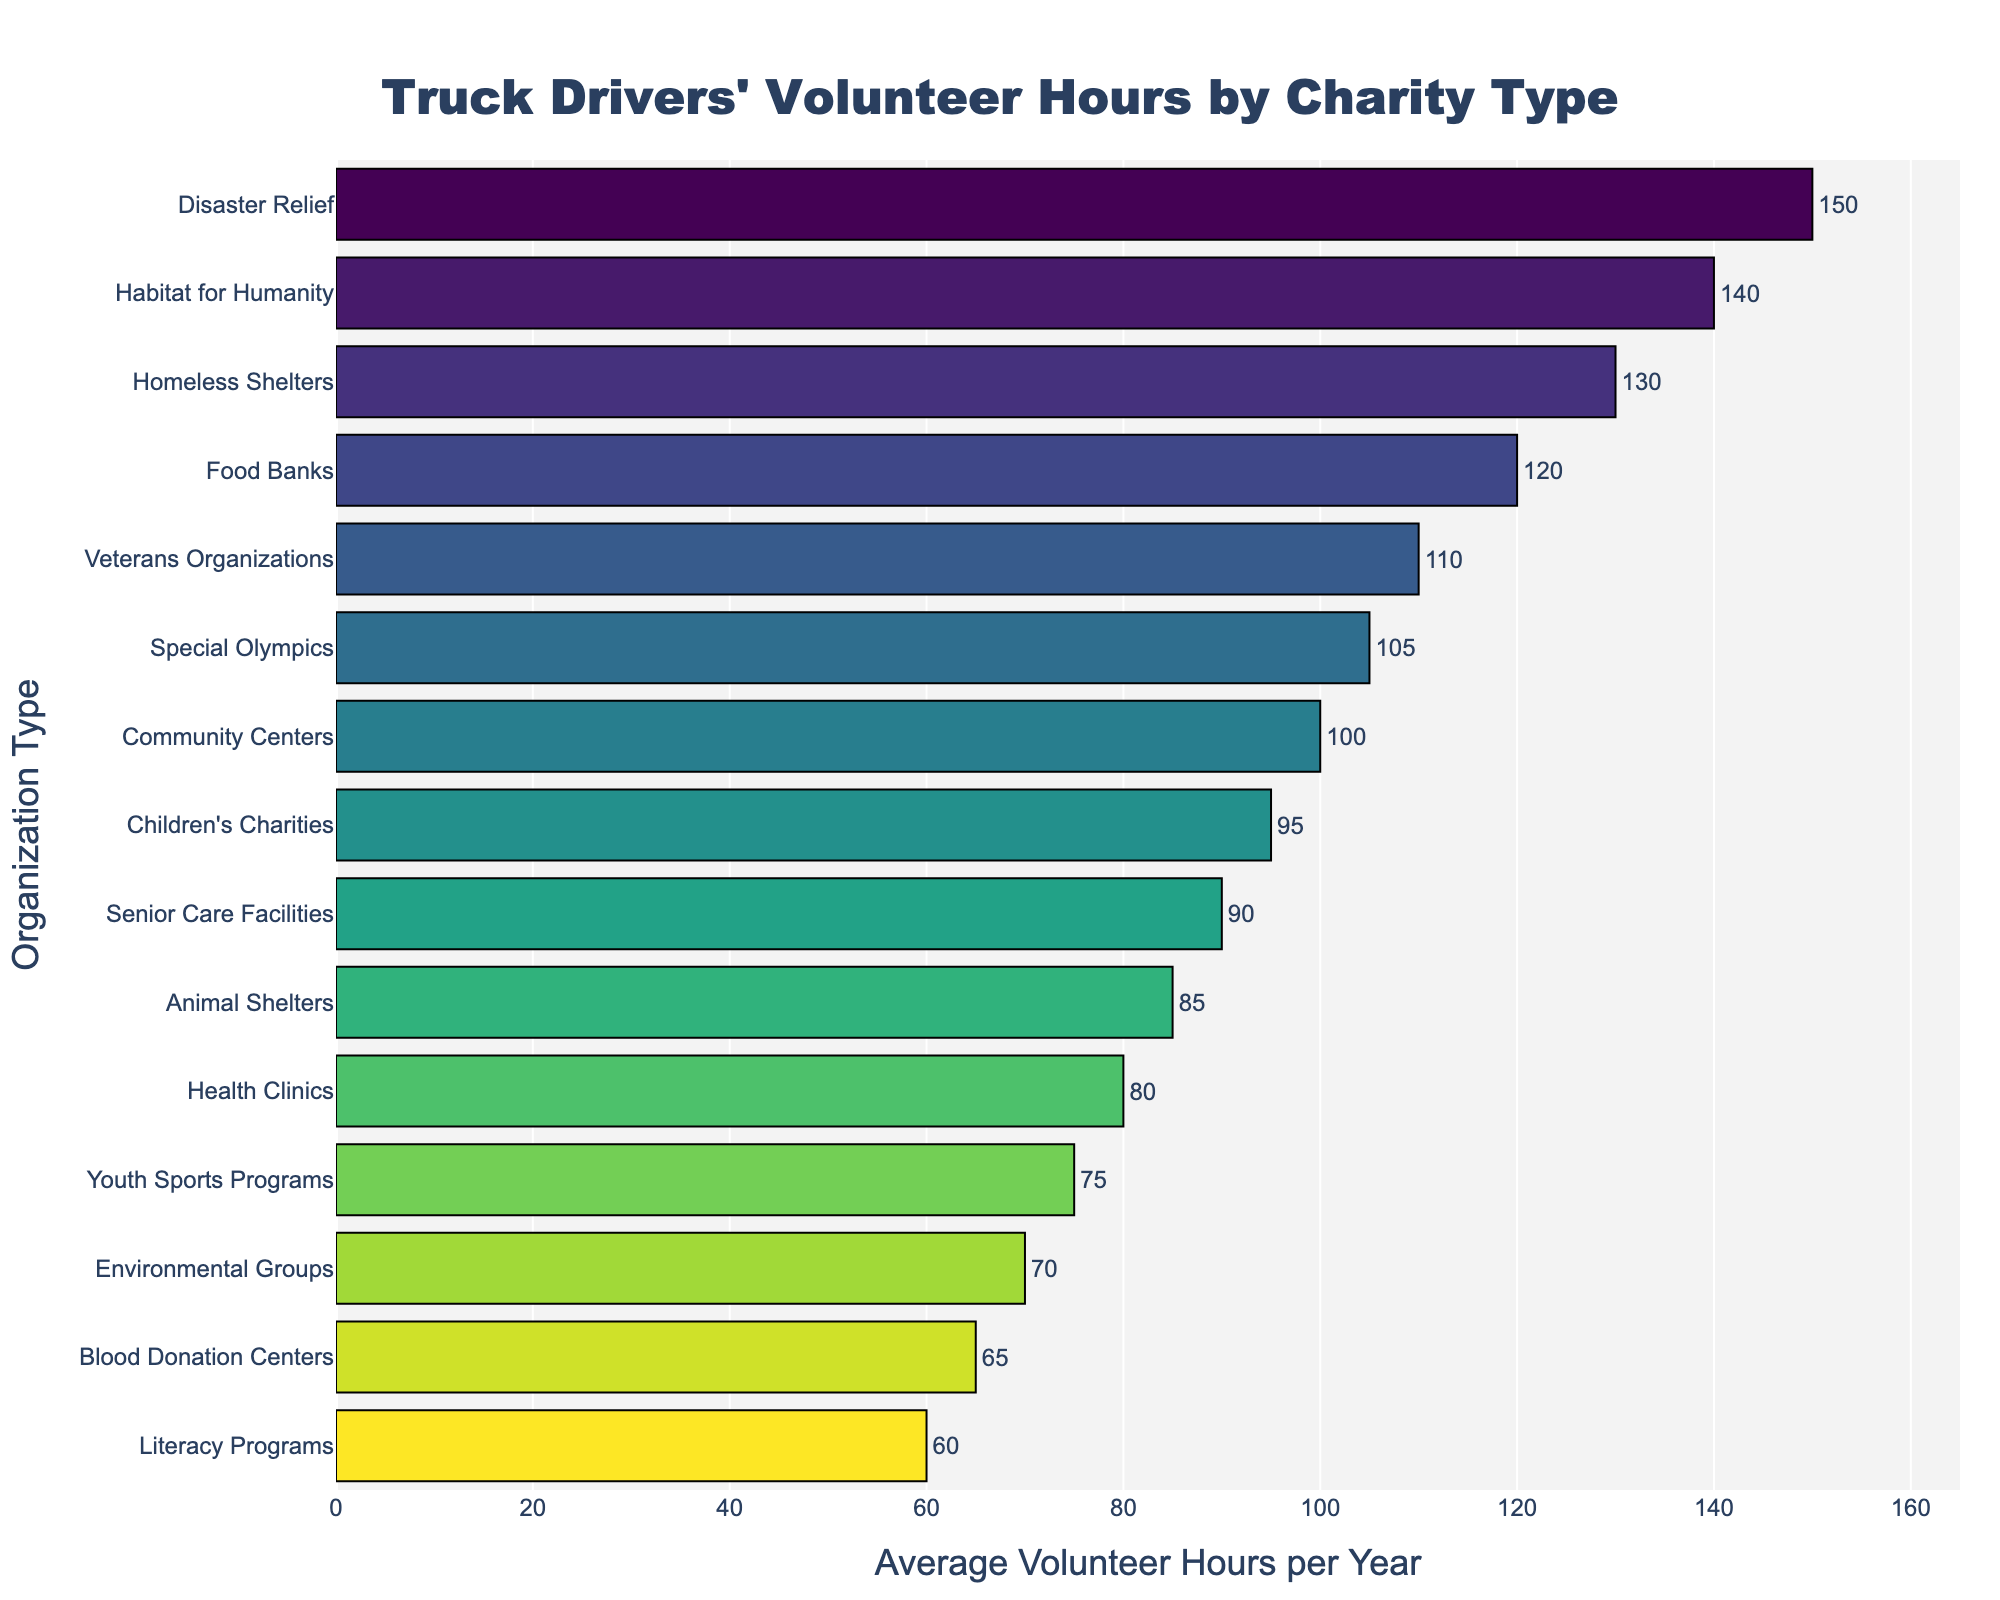Which organization type has the highest average volunteer hours? The organization type with the highest bar or the longest horizontal bar represents the highest average volunteer hours.
Answer: Disaster Relief What is the difference in average volunteer hours between Disaster Relief and Environmental Groups? Find the average volunteer hours for Disaster Relief (150) and Environmental Groups (70), then calculate the difference: 150 - 70.
Answer: 80 How many organization types have more than 100 average volunteer hours per year? Count the number of bars that extend beyond the 100-hour mark on the x-axis. The relevant organizations are Food Banks, Disaster Relief, Homeless Shelters, Habitat for Humanity, Veterans Organizations, Special Olympics.
Answer: 6 Which organization type has the shortest average volunteer hours, and what is the value? Look for the shortest bar in the bar chart, representing the least average volunteer hours per year.
Answer: Literacy Programs, 60 Are there more organization types with average volunteer hours above 100 or below 100? Count the number of bars that are above 100 (6) and those below 100 (9), then compare the counts.
Answer: Below 100 What is the combined average volunteer hours for Food Banks, Children’s Charities, and Veterans Organizations? Sum the average volunteer hours for these organizations: Food Banks (120) + Children’s Charities (95) + Veterans Organizations (110).
Answer: 325 Which organization types have average volunteer hours within a range of 60 to 80 hours? Identify bars that fall within this range on the x-axis: Literacy Programs (60), Blood Donation Centers (65), Youth Sports Programs (75), and Health Clinics (80).
Answer: Literacy Programs, Blood Donation Centers, Youth Sports Programs, Health Clinics What is the average volunteer hours for the top three organization types combined? Find the top three organization types based on the length of the bars: Disaster Relief (150), Habitat for Humanity (140), Homeless Shelters (130). Then sum these values: 150 + 140 + 130.
Answer: 420 Is there any organization type with exactly half the average volunteer hours of Veterans Organizations? Veterans Organizations have 110 hours. Look for a bar that represents 55 hours. There is no bar at this length.
Answer: No Which is greater, the average volunteer hours for Community Centers or Animal Shelters? By how much? Compare the average volunteer hours for Community Centers (100) and Animal Shelters (85). The difference is calculated: 100 - 85.
Answer: Community Centers, 15 